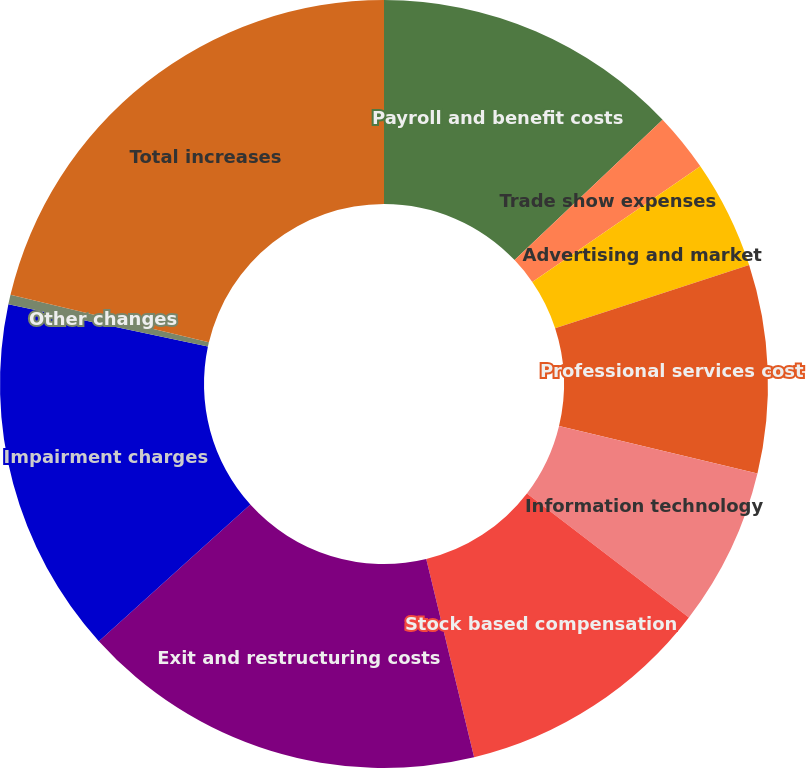Convert chart. <chart><loc_0><loc_0><loc_500><loc_500><pie_chart><fcel>Payroll and benefit costs<fcel>Trade show expenses<fcel>Advertising and market<fcel>Professional services cost<fcel>Information technology<fcel>Stock based compensation<fcel>Exit and restructuring costs<fcel>Impairment charges<fcel>Other changes<fcel>Total increases<nl><fcel>12.92%<fcel>2.49%<fcel>4.58%<fcel>8.75%<fcel>6.66%<fcel>10.83%<fcel>17.09%<fcel>15.01%<fcel>0.4%<fcel>21.27%<nl></chart> 